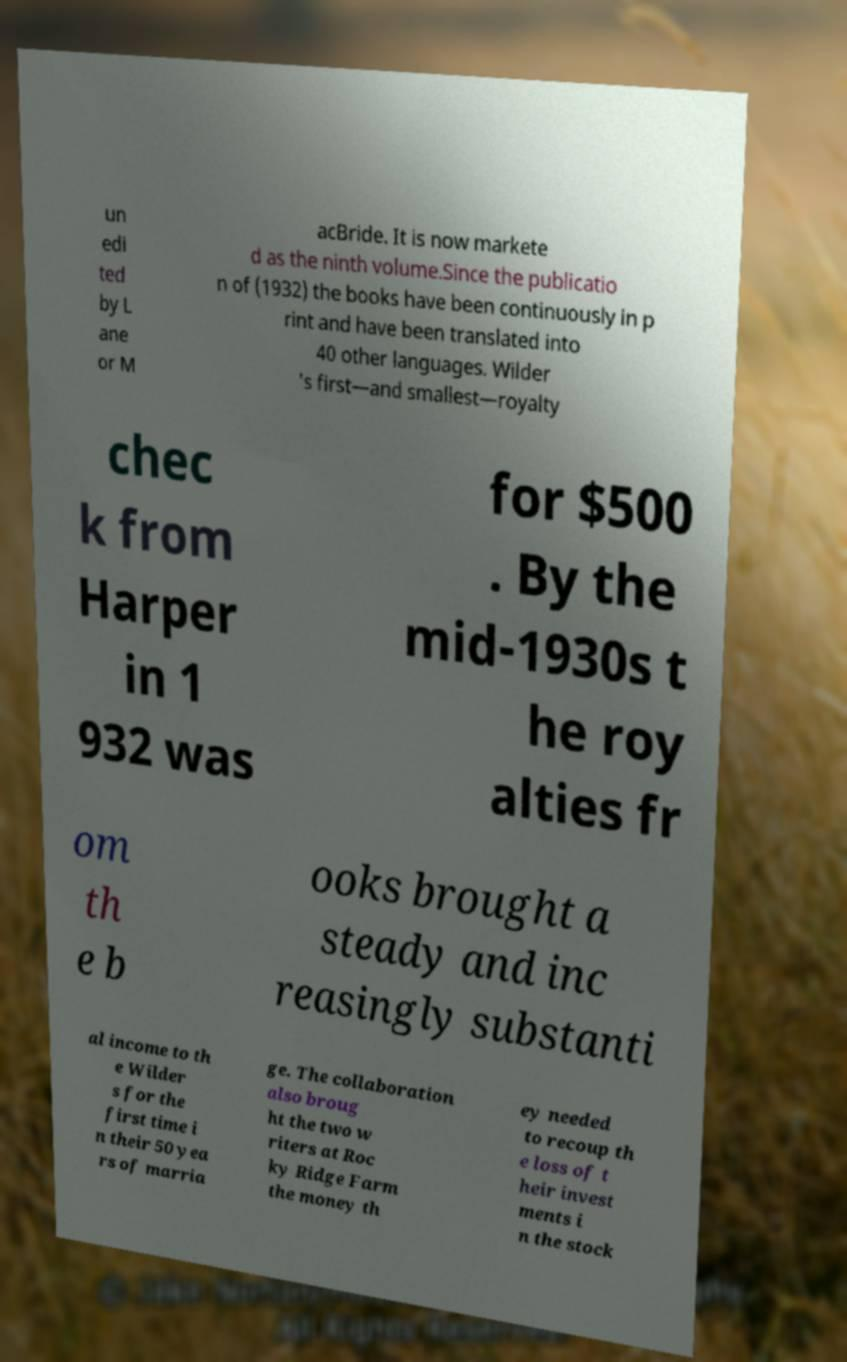Can you accurately transcribe the text from the provided image for me? un edi ted by L ane or M acBride. It is now markete d as the ninth volume.Since the publicatio n of (1932) the books have been continuously in p rint and have been translated into 40 other languages. Wilder 's first—and smallest—royalty chec k from Harper in 1 932 was for $500 . By the mid-1930s t he roy alties fr om th e b ooks brought a steady and inc reasingly substanti al income to th e Wilder s for the first time i n their 50 yea rs of marria ge. The collaboration also broug ht the two w riters at Roc ky Ridge Farm the money th ey needed to recoup th e loss of t heir invest ments i n the stock 